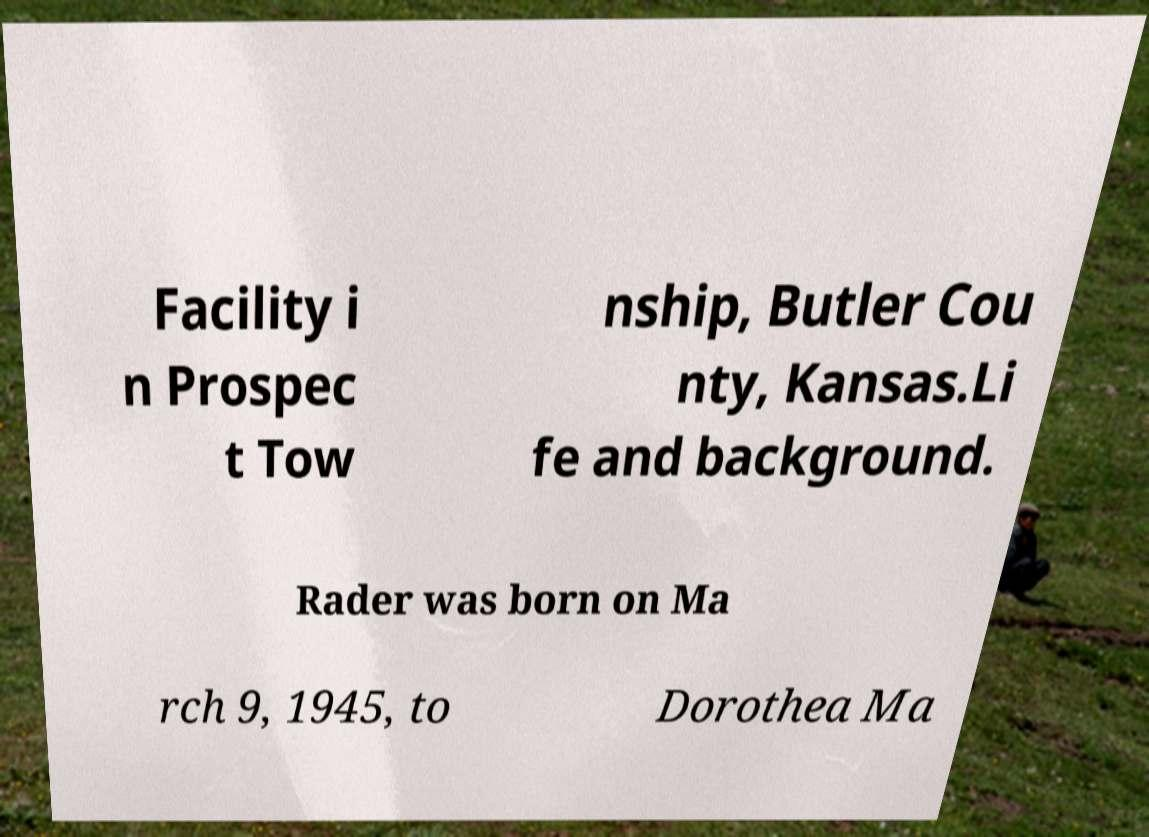Can you accurately transcribe the text from the provided image for me? Facility i n Prospec t Tow nship, Butler Cou nty, Kansas.Li fe and background. Rader was born on Ma rch 9, 1945, to Dorothea Ma 